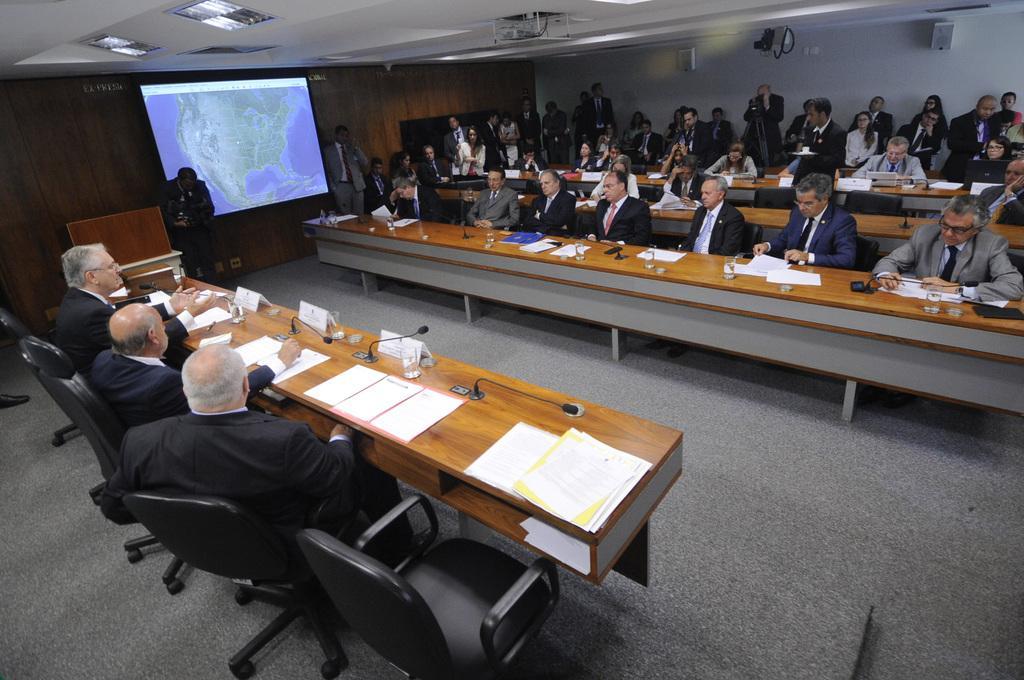How would you summarize this image in a sentence or two? In this picture we can see some persons are sitting on the chairs. These are the tables, on the table there is a paper. And these are the mikes. And even we can see the screen here. This is the floor and this is the wall. 